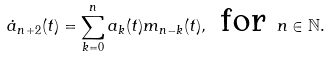Convert formula to latex. <formula><loc_0><loc_0><loc_500><loc_500>\dot { a } _ { n + 2 } ( t ) = \sum _ { k = 0 } ^ { n } a _ { k } ( t ) m _ { n - k } ( t ) , \text { for } n \in \mathbb { N } .</formula> 